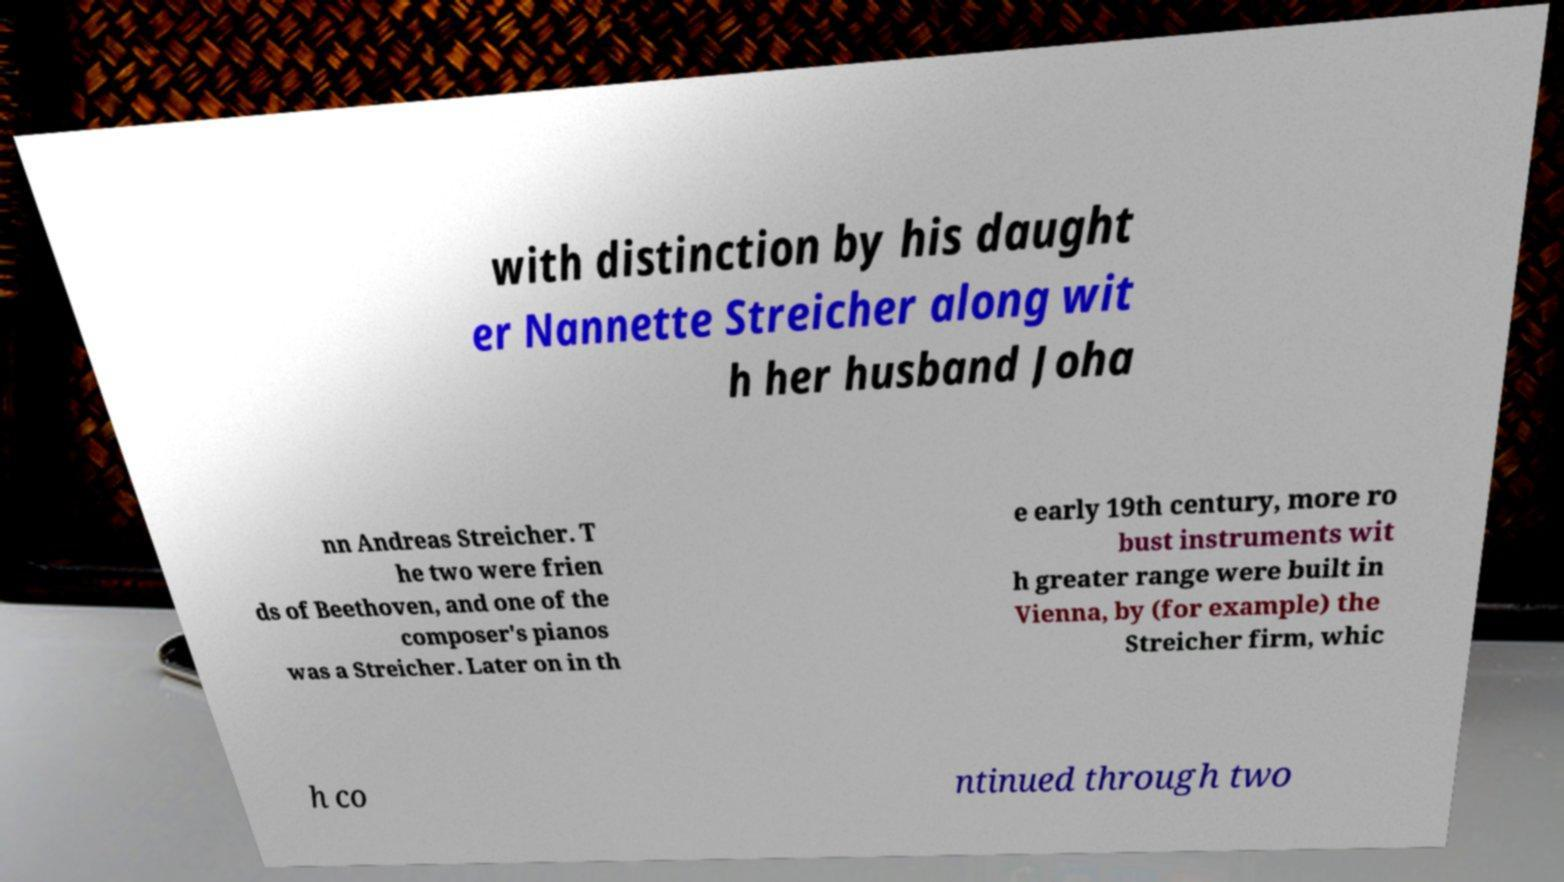Please read and relay the text visible in this image. What does it say? with distinction by his daught er Nannette Streicher along wit h her husband Joha nn Andreas Streicher. T he two were frien ds of Beethoven, and one of the composer's pianos was a Streicher. Later on in th e early 19th century, more ro bust instruments wit h greater range were built in Vienna, by (for example) the Streicher firm, whic h co ntinued through two 